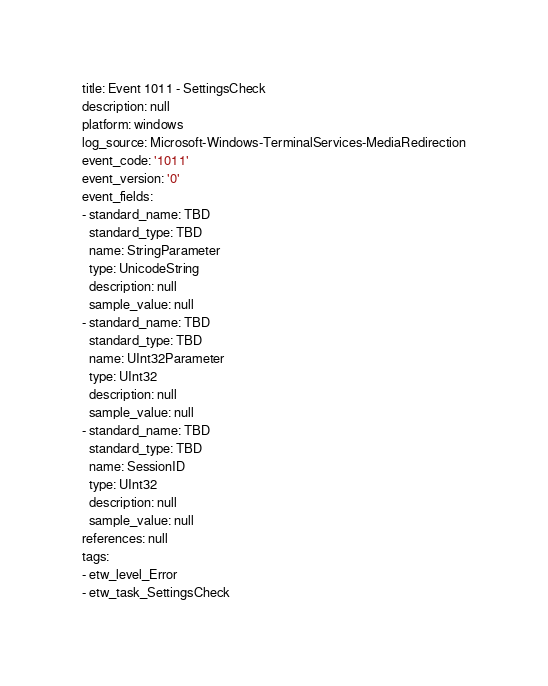<code> <loc_0><loc_0><loc_500><loc_500><_YAML_>title: Event 1011 - SettingsCheck
description: null
platform: windows
log_source: Microsoft-Windows-TerminalServices-MediaRedirection
event_code: '1011'
event_version: '0'
event_fields:
- standard_name: TBD
  standard_type: TBD
  name: StringParameter
  type: UnicodeString
  description: null
  sample_value: null
- standard_name: TBD
  standard_type: TBD
  name: UInt32Parameter
  type: UInt32
  description: null
  sample_value: null
- standard_name: TBD
  standard_type: TBD
  name: SessionID
  type: UInt32
  description: null
  sample_value: null
references: null
tags:
- etw_level_Error
- etw_task_SettingsCheck
</code> 